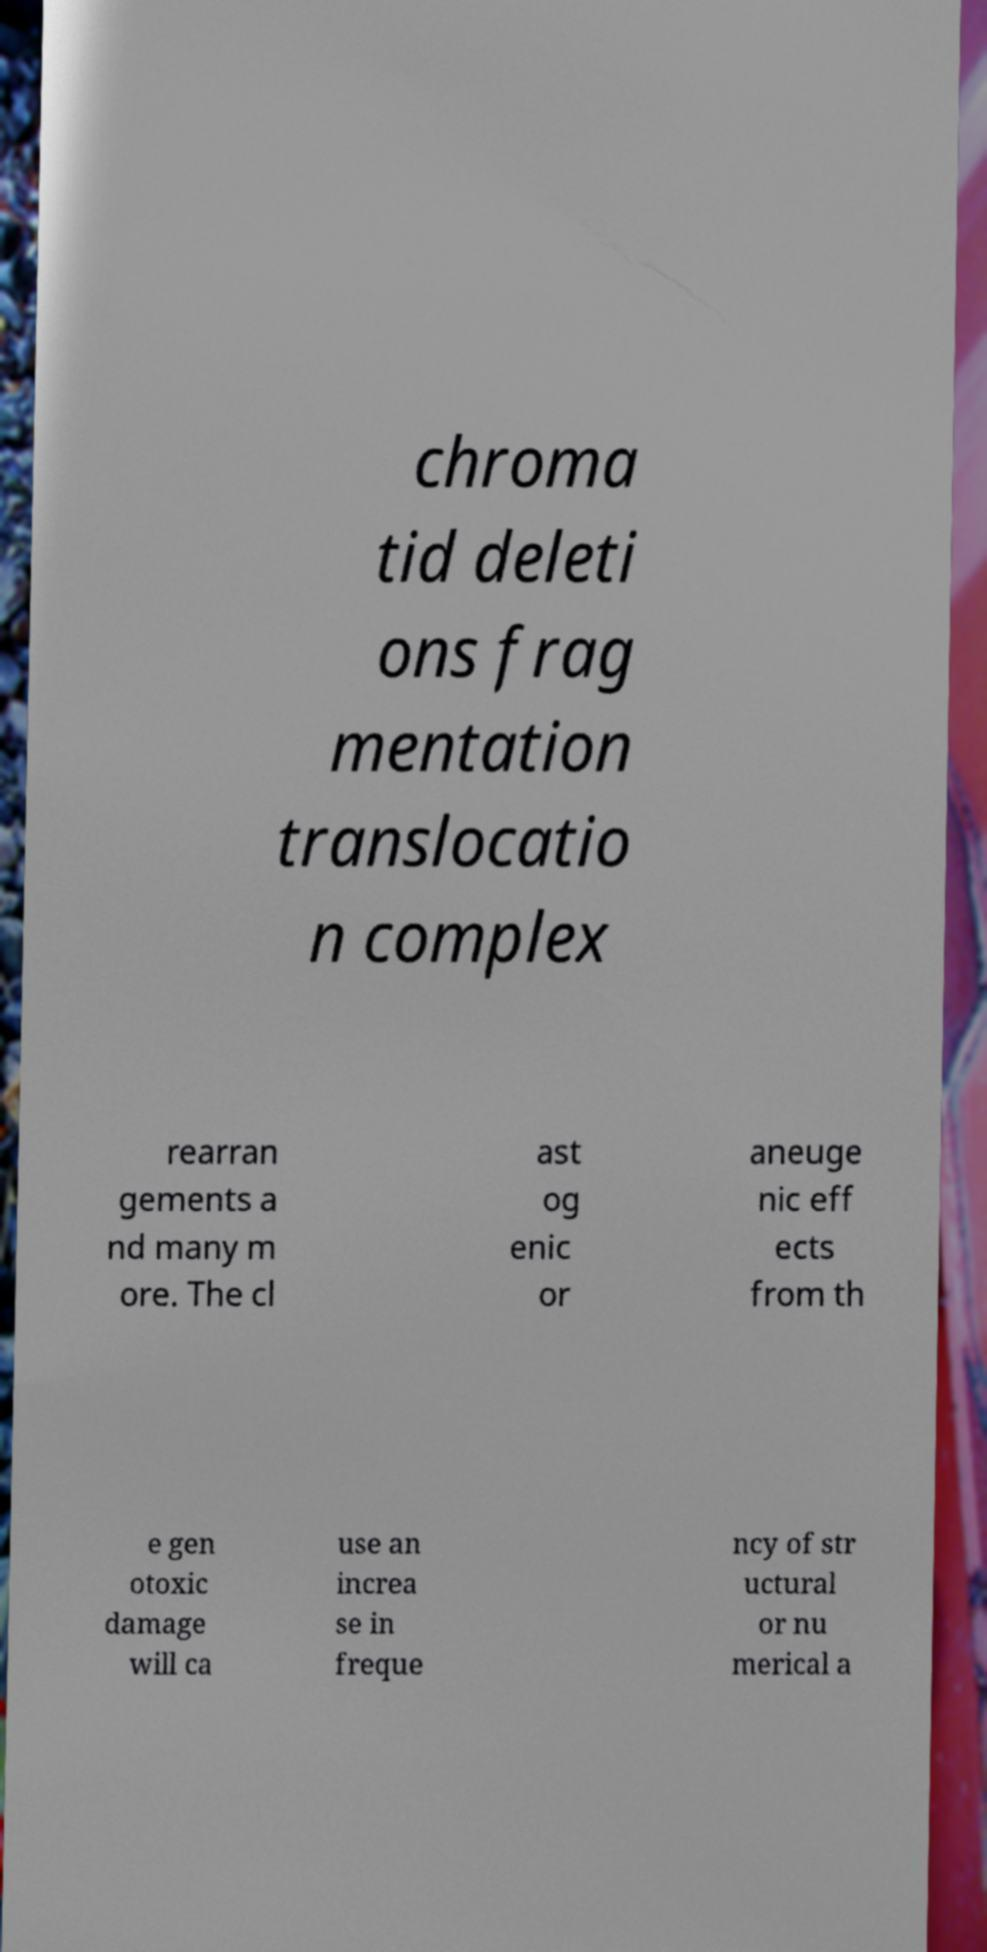I need the written content from this picture converted into text. Can you do that? chroma tid deleti ons frag mentation translocatio n complex rearran gements a nd many m ore. The cl ast og enic or aneuge nic eff ects from th e gen otoxic damage will ca use an increa se in freque ncy of str uctural or nu merical a 